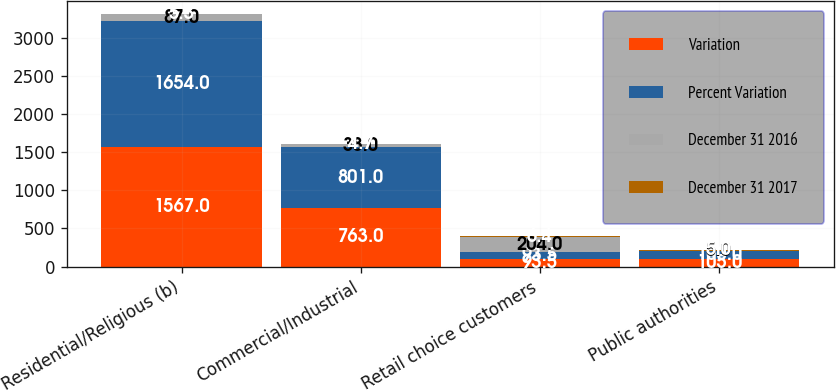Convert chart. <chart><loc_0><loc_0><loc_500><loc_500><stacked_bar_chart><ecel><fcel>Residential/Religious (b)<fcel>Commercial/Industrial<fcel>Retail choice customers<fcel>Public authorities<nl><fcel>Variation<fcel>1567<fcel>763<fcel>93.5<fcel>105<nl><fcel>Percent Variation<fcel>1654<fcel>801<fcel>93.5<fcel>100<nl><fcel>December 31 2016<fcel>87<fcel>38<fcel>204<fcel>5<nl><fcel>December 31 2017<fcel>5.3<fcel>4.7<fcel>6.4<fcel>5<nl></chart> 